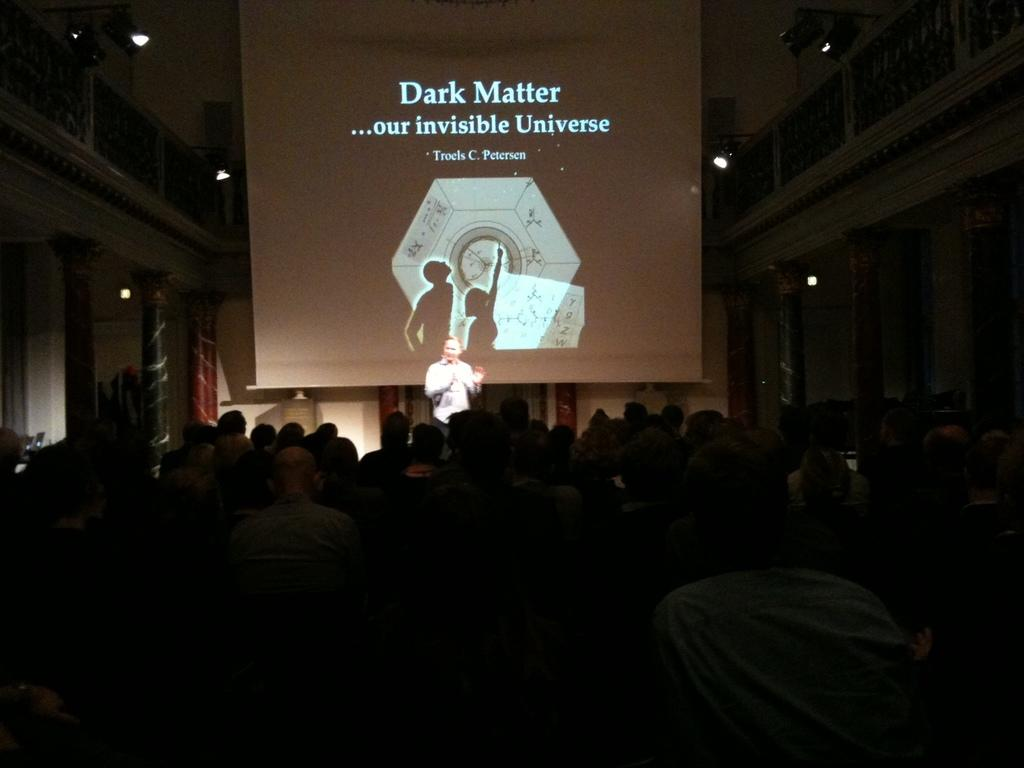How many people are in the image? There is a group of people in the image. Can you describe the position of the man in the image? There is a man in front of the group. What is in front of the group? There is a screen in front of the group. What architectural features can be seen in the image? There are pillars in the image. What can be seen in the image that provides illumination? There are lights in the image. What objects are present in front of the group? There are some objects in front of the group. How many ants can be seen crawling on the man's mind in the image? There are no ants or references to a man's mind in the image; it features a group of people with a man in front of them. 